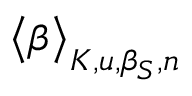<formula> <loc_0><loc_0><loc_500><loc_500>\Big < \beta \Big > _ { K , u , \beta _ { S } , n }</formula> 